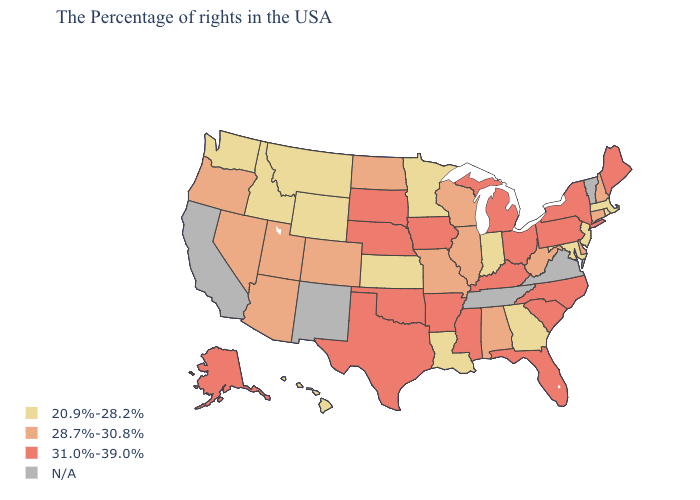What is the highest value in states that border Florida?
Quick response, please. 28.7%-30.8%. Which states have the highest value in the USA?
Short answer required. Maine, New York, Pennsylvania, North Carolina, South Carolina, Ohio, Florida, Michigan, Kentucky, Mississippi, Arkansas, Iowa, Nebraska, Oklahoma, Texas, South Dakota, Alaska. Does Louisiana have the lowest value in the USA?
Be succinct. Yes. What is the value of Idaho?
Write a very short answer. 20.9%-28.2%. Is the legend a continuous bar?
Concise answer only. No. Which states have the lowest value in the USA?
Short answer required. Massachusetts, Rhode Island, New Jersey, Maryland, Georgia, Indiana, Louisiana, Minnesota, Kansas, Wyoming, Montana, Idaho, Washington, Hawaii. Does South Dakota have the lowest value in the MidWest?
Write a very short answer. No. What is the highest value in states that border Florida?
Concise answer only. 28.7%-30.8%. What is the highest value in the USA?
Be succinct. 31.0%-39.0%. Does the map have missing data?
Be succinct. Yes. Is the legend a continuous bar?
Answer briefly. No. How many symbols are there in the legend?
Write a very short answer. 4. Name the states that have a value in the range N/A?
Quick response, please. Vermont, Virginia, Tennessee, New Mexico, California. Name the states that have a value in the range N/A?
Answer briefly. Vermont, Virginia, Tennessee, New Mexico, California. 